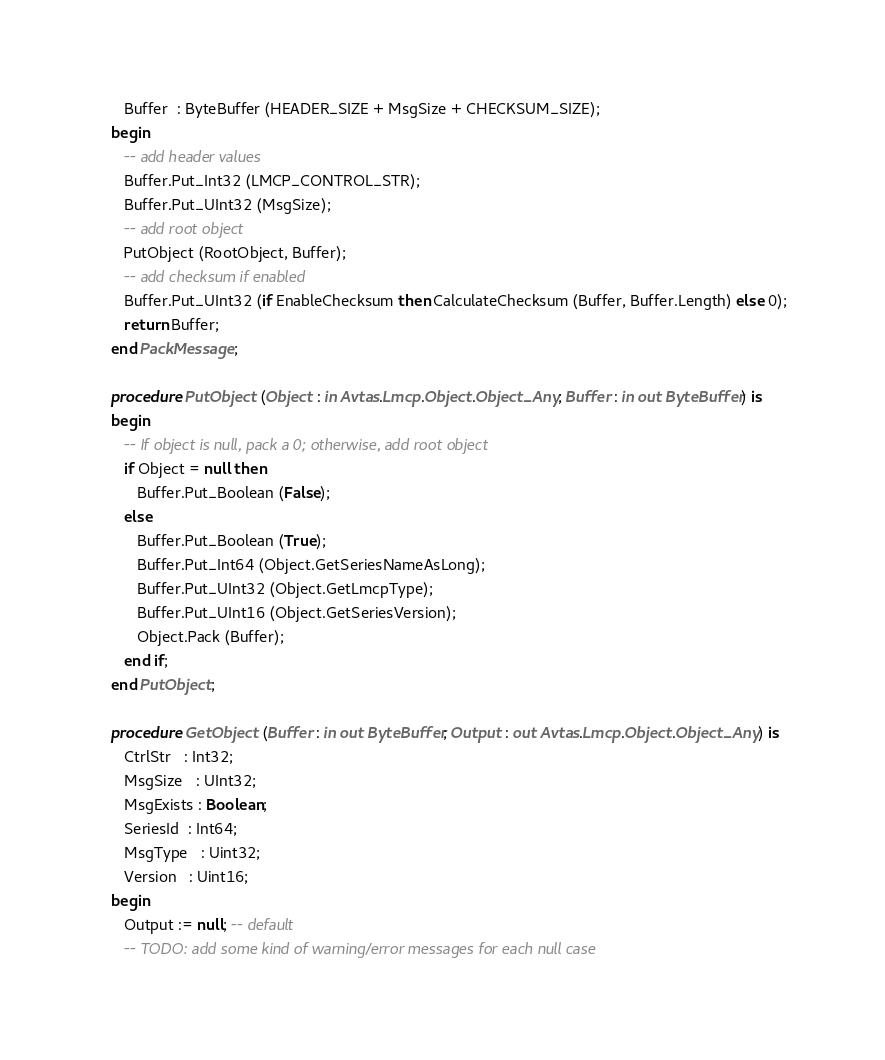<code> <loc_0><loc_0><loc_500><loc_500><_Ada_>      Buffer  : ByteBuffer (HEADER_SIZE + MsgSize + CHECKSUM_SIZE);
   begin
      -- add header values
      Buffer.Put_Int32 (LMCP_CONTROL_STR);
      Buffer.Put_UInt32 (MsgSize);
      -- add root object
      PutObject (RootObject, Buffer);
      -- add checksum if enabled
      Buffer.Put_UInt32 (if EnableChecksum then CalculateChecksum (Buffer, Buffer.Length) else 0);
      return Buffer;
   end PackMessage;

   procedure PutObject (Object : in Avtas.Lmcp.Object.Object_Any; Buffer : in out ByteBuffer) is
   begin
      -- If object is null, pack a 0; otherwise, add root object
      if Object = null then
         Buffer.Put_Boolean (False);
      else
         Buffer.Put_Boolean (True);
         Buffer.Put_Int64 (Object.GetSeriesNameAsLong);
         Buffer.Put_UInt32 (Object.GetLmcpType);
         Buffer.Put_UInt16 (Object.GetSeriesVersion);
         Object.Pack (Buffer);
      end if;
   end PutObject;

   procedure GetObject (Buffer : in out ByteBuffer; Output : out Avtas.Lmcp.Object.Object_Any) is
      CtrlStr   : Int32;
      MsgSize   : UInt32;
      MsgExists : Boolean;
      SeriesId  : Int64;
      MsgType   : Uint32;
      Version   : Uint16;
   begin
      Output := null; -- default
      -- TODO: add some kind of warning/error messages for each null case</code> 